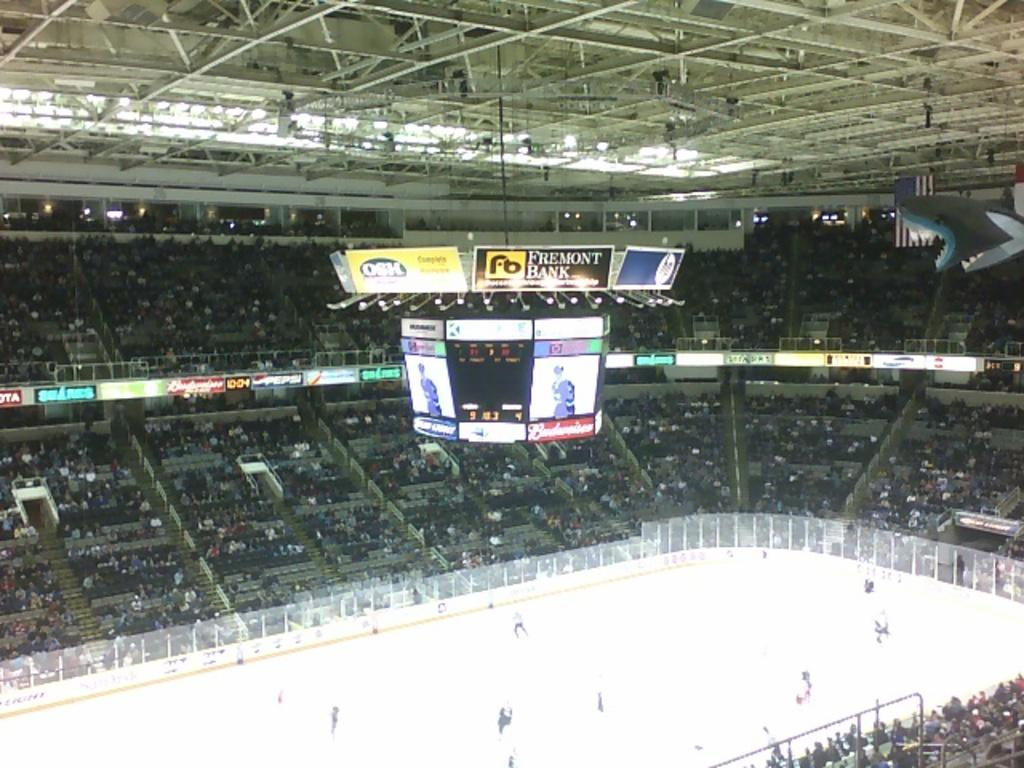Provide a one-sentence caption for the provided image. An ice arena with the center sign saying it is sponsored by Fremont Bank. 